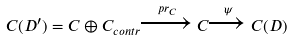Convert formula to latex. <formula><loc_0><loc_0><loc_500><loc_500>C ( D ^ { \prime } ) = C \oplus C _ { c o n t r } \xrightarrow { p r _ { C } } C \xrightarrow { \psi } C ( D )</formula> 